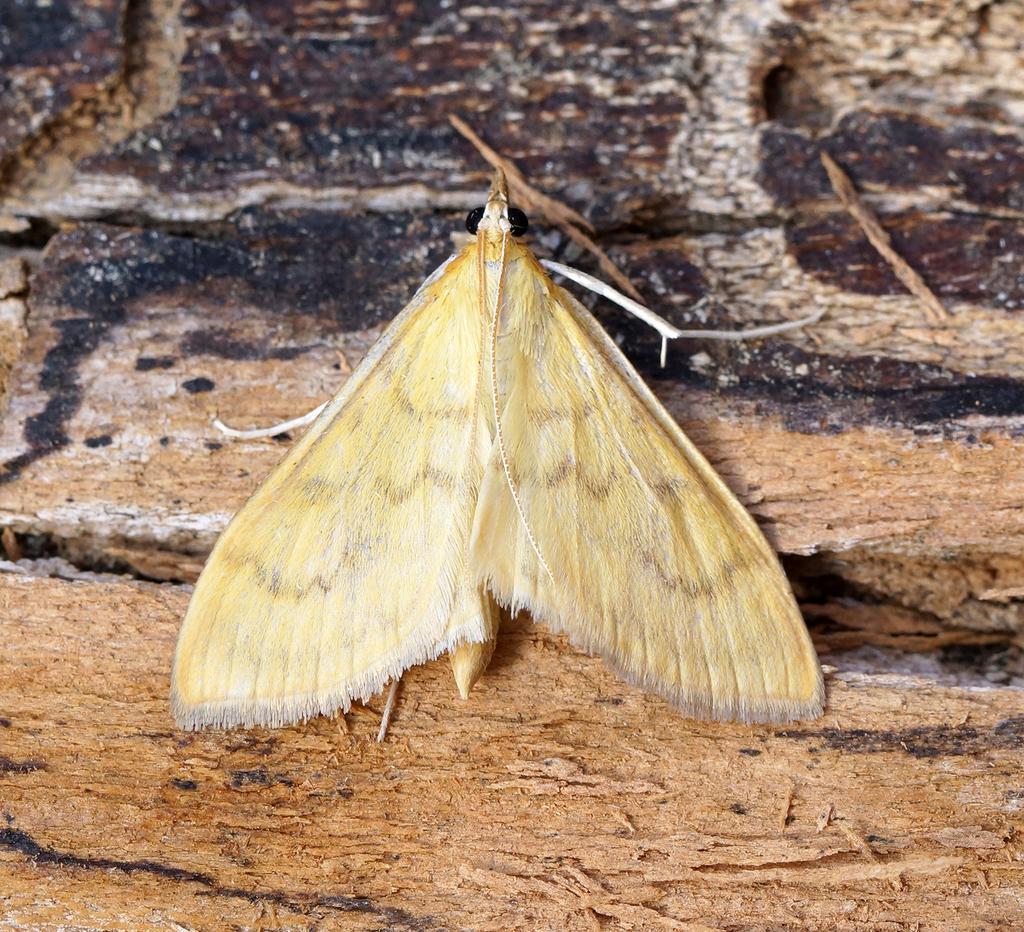Describe this image in one or two sentences. In this picture I can see the butterfly on the table. 